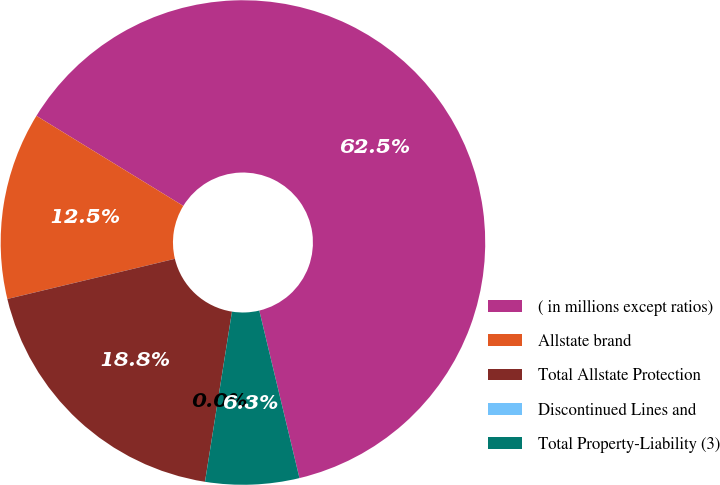Convert chart to OTSL. <chart><loc_0><loc_0><loc_500><loc_500><pie_chart><fcel>( in millions except ratios)<fcel>Allstate brand<fcel>Total Allstate Protection<fcel>Discontinued Lines and<fcel>Total Property-Liability (3)<nl><fcel>62.49%<fcel>12.5%<fcel>18.75%<fcel>0.0%<fcel>6.25%<nl></chart> 